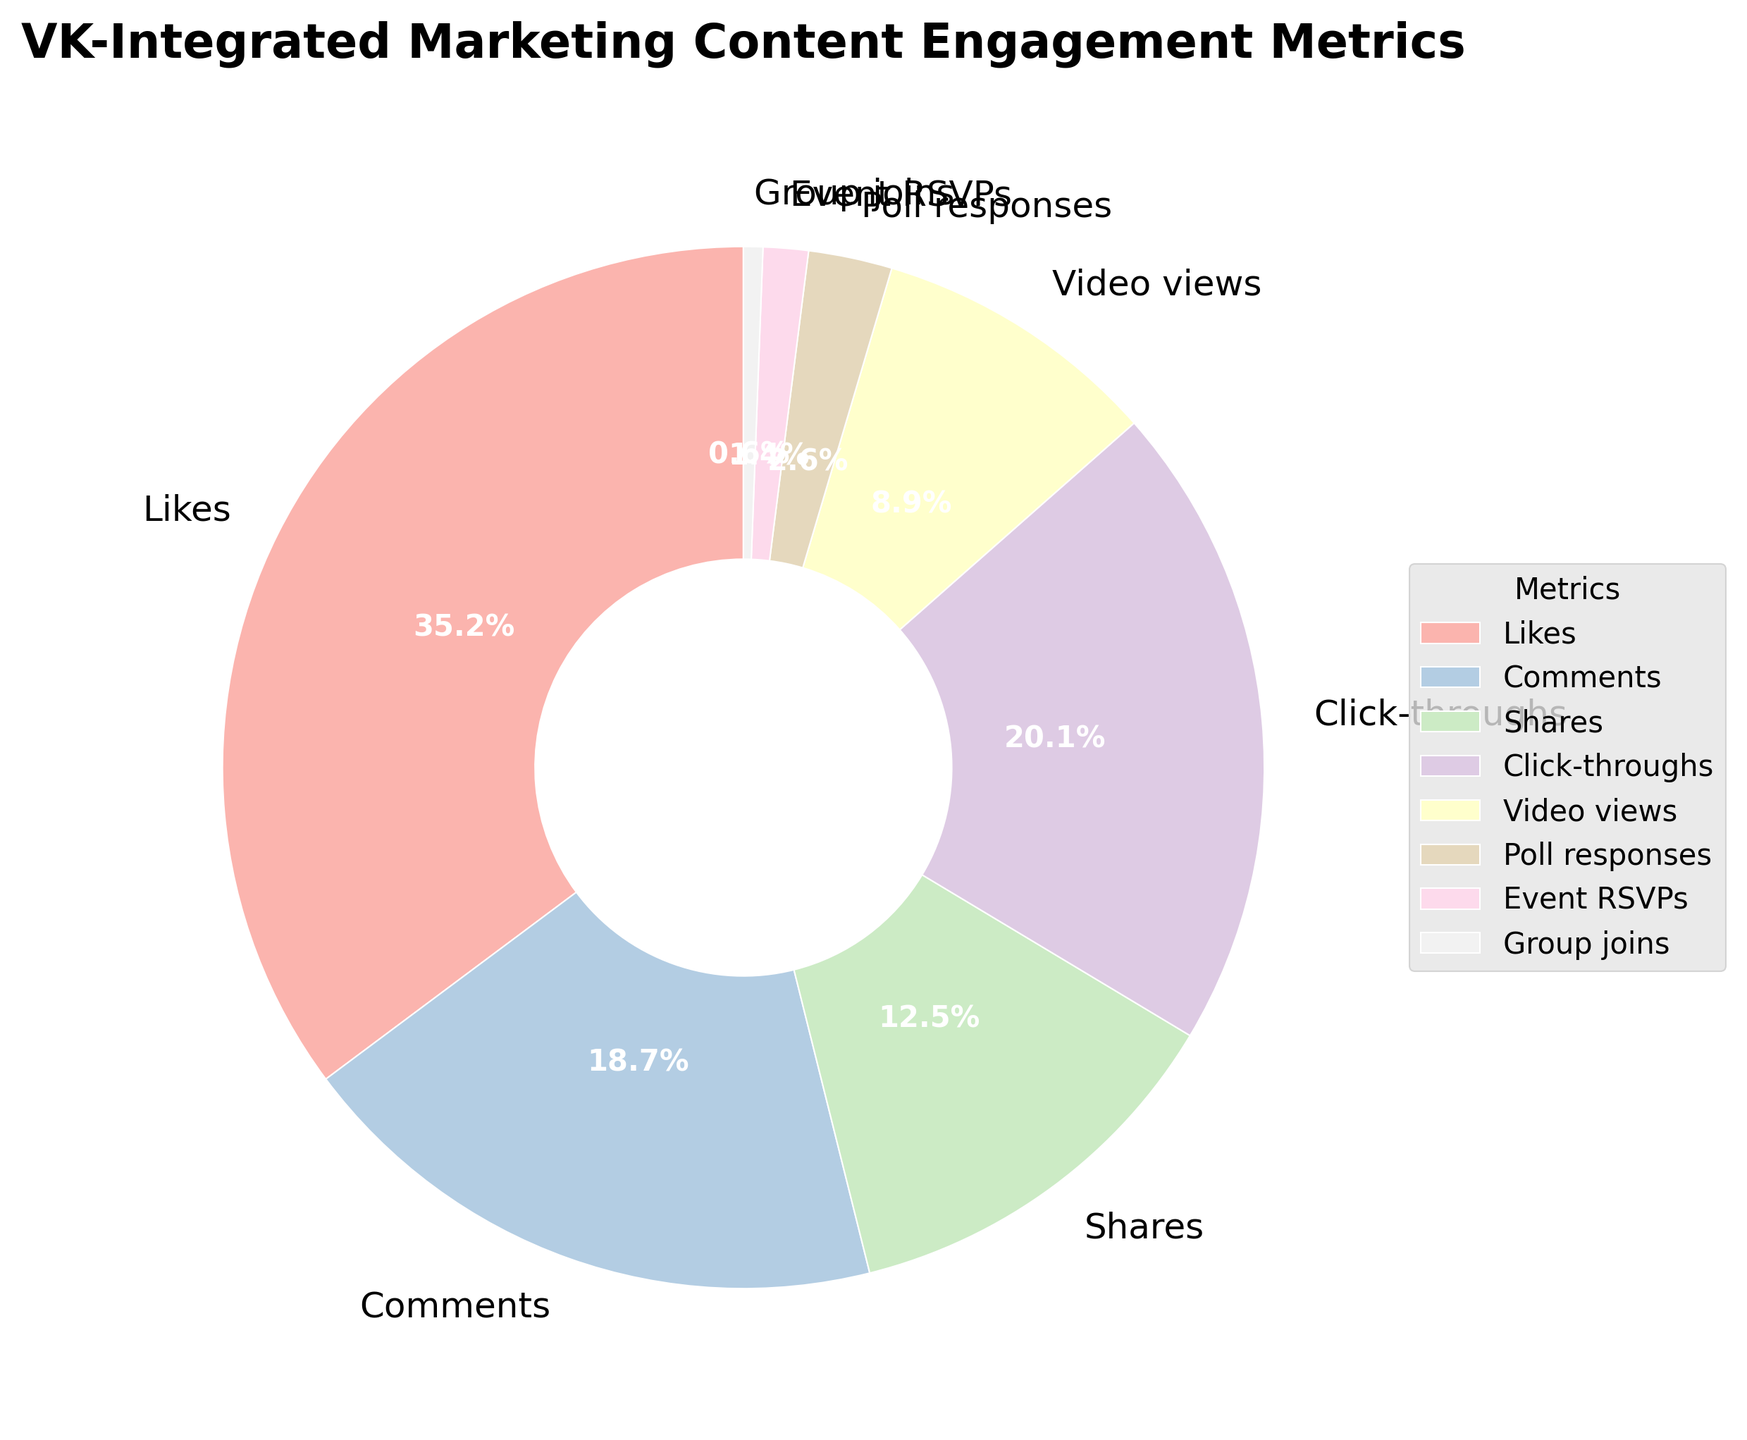Which metric has the highest engagement percentage? The figure shows the pie chart with different segments representing the various metrics. The largest segment corresponds to the metric with the highest percentage.
Answer: Likes What's the combined percentage of Comments and Shares? Locate the segments for Comments and Shares. Note their individual percentages, then sum them: 18.7% (Comments) + 12.5% (Shares).
Answer: 31.2% How much higher is the Click-throughs percentage compared to Poll responses? Identify the percentages for Click-throughs (20.1%) and Poll responses (2.6%). Subtract the smaller percentage from the larger one: 20.1% - 2.6%.
Answer: 17.5% Which metric has the smallest engagement percentage? The pie chart segments represent metric percentages. The smallest segment corresponds to the metric with the smallest percentage.
Answer: Group joins Are Video views higher than Event RSVPs? Compare the segments for Video views (8.9%) and Event RSVPs (1.4%). Video views have a higher percentage.
Answer: Yes What is the difference in percentage between Shares and Group joins? Locate the percentages for Shares (12.5%) and Group joins (0.6%). Subtract the smaller percentage from the larger one: 12.5% - 0.6%.
Answer: 11.9% What is the combined percentage of metrics with engagement below 10%? Identify metrics with percentages below 10%: Video views (8.9%), Poll responses (2.6%), Event RSVPs (1.4%), Group joins (0.6%). Sum them up: 8.9% + 2.6% + 1.4% + 0.6%.
Answer: 13.5% Which metric has the third highest engagement percentage? Order the percentages from highest to lowest: Likes (35.2%), Click-throughs (20.1%), Comments (18.7%). The third highest is Comments.
Answer: Comments How much more engaged are users through Click-throughs compared to Group joins? Identify the percentages for Click-throughs (20.1%) and Group joins (0.6%). Subtract the smaller percentage from the larger one: 20.1% - 0.6%.
Answer: 19.5% Which two metrics, when combined, have the highest total engagement percentage? Sum the percentages of all possible metric pairs and compare: Likes (35.2%) + Click-throughs (20.1%) = 55.3%, Likes + Comments (18.7%) = 53.9%, and so on. The highest combined percentage is from Likes and Click-throughs.
Answer: Likes and Click-throughs 